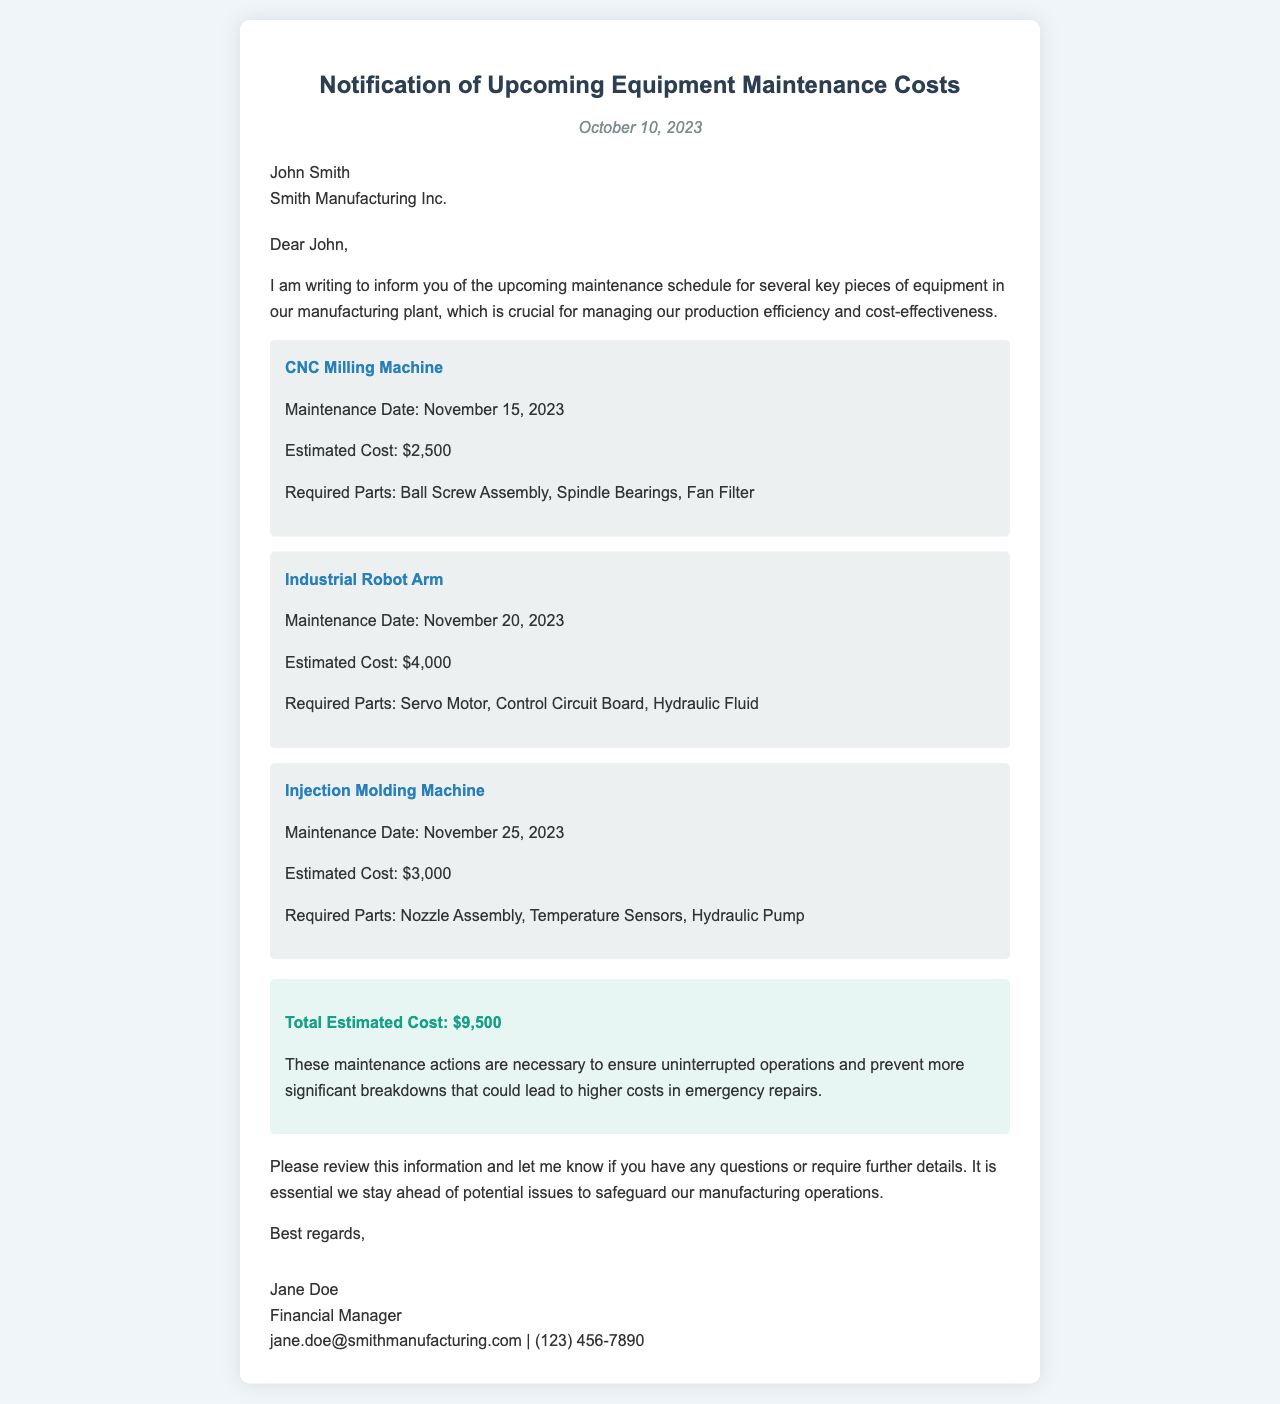what is the maintenance date for the CNC Milling Machine? The maintenance date for the CNC Milling Machine is specified in the equipment list.
Answer: November 15, 2023 what is the total estimated cost for the upcoming maintenance? The total estimated cost is presented in the budget summary section of the document.
Answer: $9,500 which part is required for the Industrial Robot Arm? The required parts for the Industrial Robot Arm are listed under its equipment item.
Answer: Servo Motor who is the sender of the letter? The sender's name and title are found in the signature section at the end of the letter.
Answer: Jane Doe what is the estimated cost for the Injection Molding Machine? The estimated cost is mentioned alongside its maintenance details in the equipment list.
Answer: $3,000 why are these maintenance actions necessary? The reason for the maintenance actions can be found in the budget summary section, emphasizing the importance of preventing larger issues.
Answer: To ensure uninterrupted operations when is the maintenance scheduled for the Industrial Robot Arm? The maintenance date for the Industrial Robot Arm is provided in the equipment list.
Answer: November 20, 2023 what is the email address of the sender? The email address of the sender can be found in the signature section of the document.
Answer: jane.doe@smithmanufacturing.com 